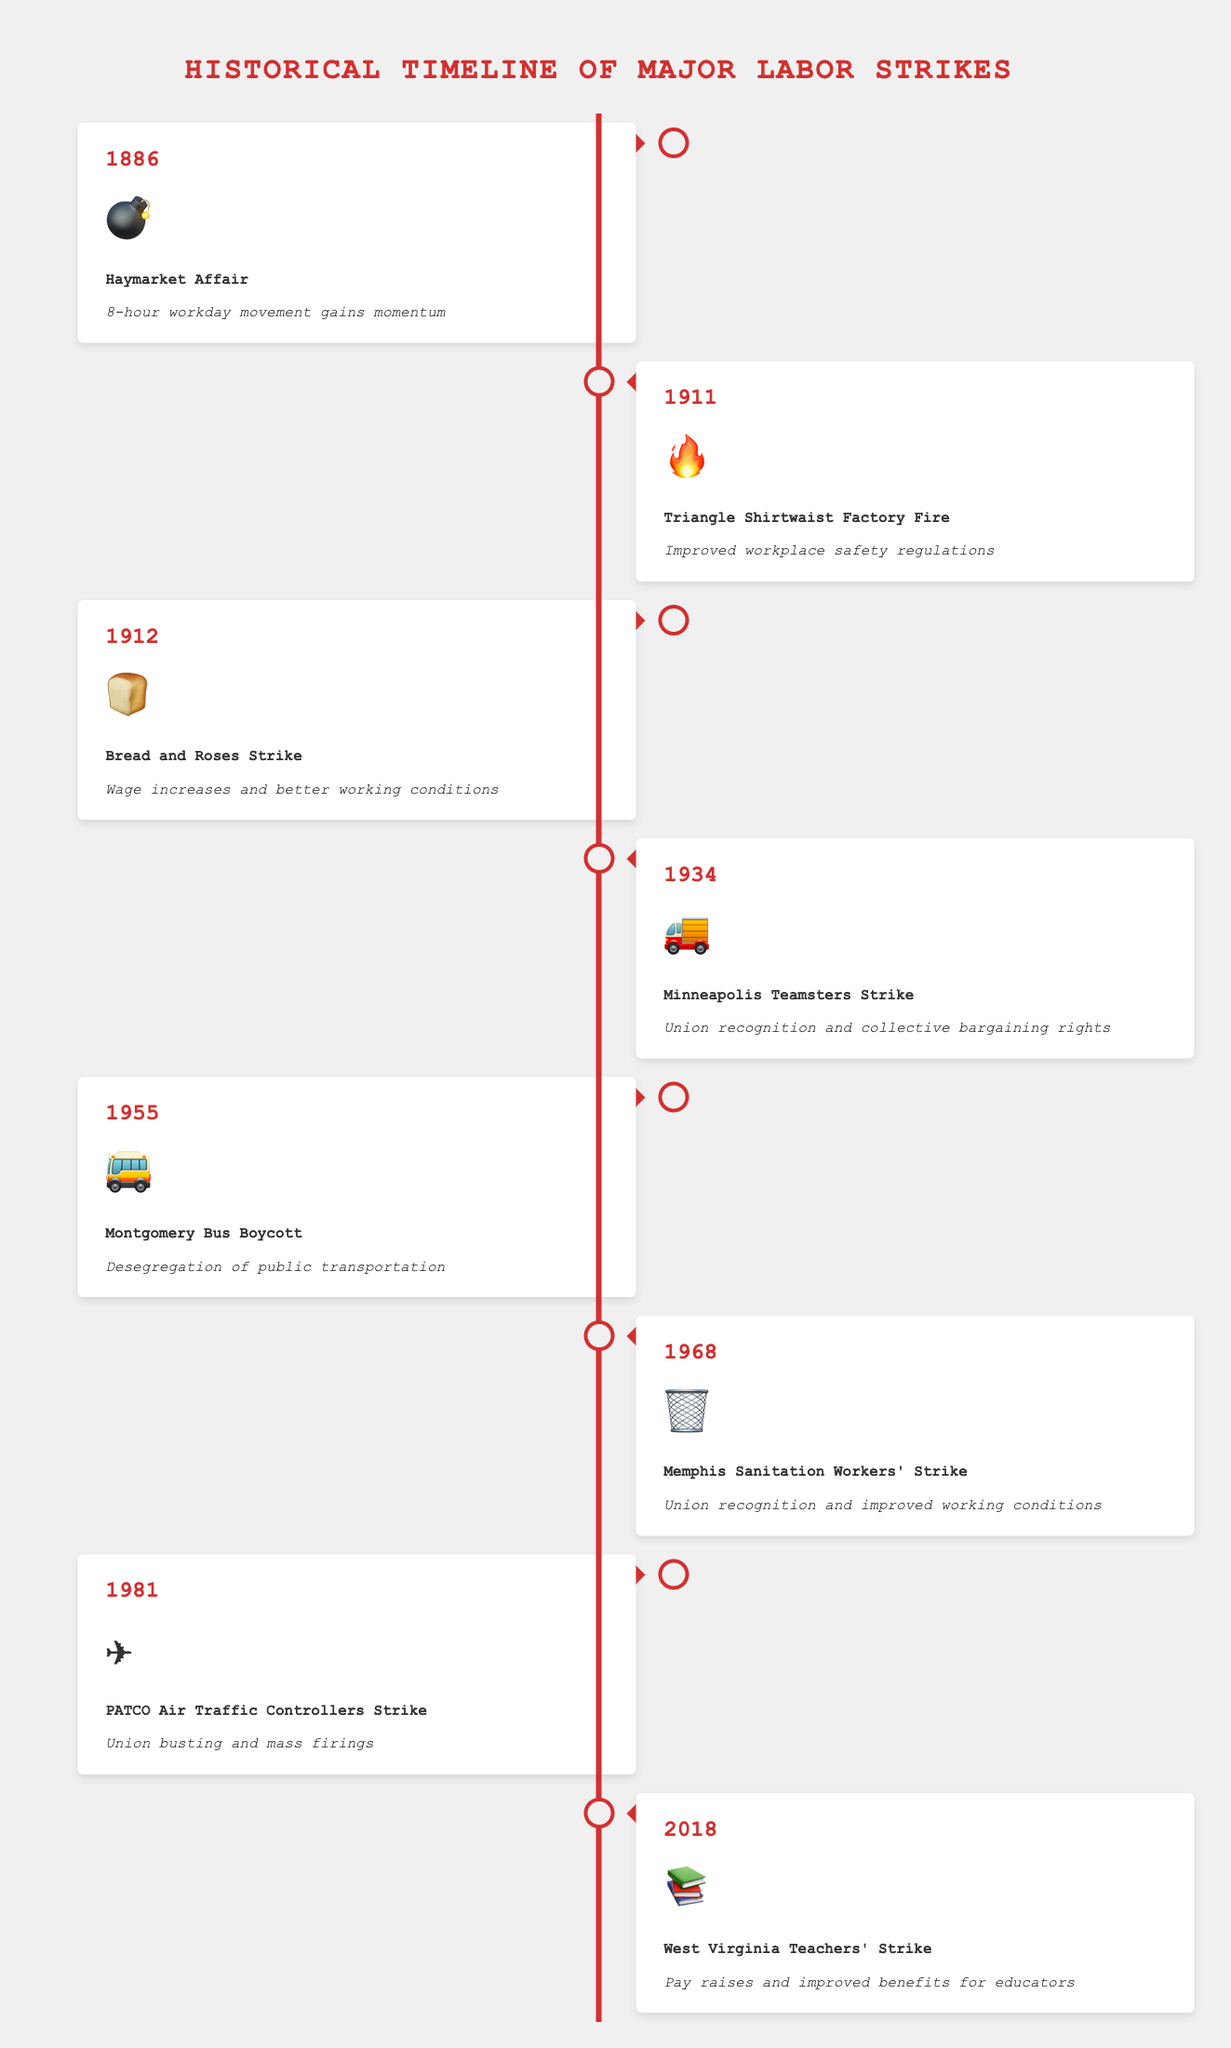When did the Haymarket Affair occur, and what was its outcome? Look for the year labeled with the 💣 emoji to identify the Haymarket Affair and read its corresponding outcome.
Answer: 1886; 8-hour workday movement gains momentum What major event happened in 1911, and what was its impact? Check the year 1911 and the associated event and outcome in the timeline.
Answer: Triangle Shirtwaist Factory Fire; Improved workplace safety regulations Which strike is represented by the 📚 emoji, and what was achieved? Locate the 📚 emoji to find the event and its outcome.
Answer: West Virginia Teachers' Strike; Pay raises and improved benefits for educators What two strikes occurred before 1955, and what were their outcomes? Identify the events before 1955, which are labeled with their respective emojis, and note their outcomes.
Answer: Haymarket Affair (1886; 8-hour workday movement gains momentum), Triangle Shirtwaist Factory Fire (1911; Improved workplace safety regulations), and Bread and Roses Strike (1912; Wage increases and better working conditions) What is the common outcome of strikes involving workplace safety reforms? Find all events related to improvements in workplace safety and summarize their outcomes.
Answer: Improved workplace safety regulations Compare the outcomes of the Memphis Sanitation Workers' Strike and PATCO Air Traffic Controllers Strike. Locate the Memphis Sanitation Workers' Strike (🗑️) and PATCO Air Traffic Controllers Strike (✈️) and read their outcomes.
Answer: Memphis: Union recognition and improved working conditions; PATCO: Union busting and mass firings Which event had the outcome of desegregation of public transportation, and in what year did it occur? Look for the event related to desegregation of public transportation and note its year.
Answer: Montgomery Bus Boycott; 1955 What were the outcomes of labor strikes that happened after 1980? Identify events after 1980 and summarize their outcomes.
Answer: PATCO Air Traffic Controllers Strike (1981; Union busting and mass firings), West Virginia Teachers' Strike (2018; Pay raises and improved benefits for educators) How many strikes between 1912 and 1968 were depicted, and what were their outcomes? Count the strikes between these years and summarize their outcomes.
Answer: Three strikes: Bread and Roses Strike (1912; Wage increases and better working conditions), Minneapolis Teamsters Strike (1934; Union recognition and collective bargaining rights), Memphis Sanitation Workers' Strike (1968; Union recognition and improved working conditions) Which strike was represented by the emoji 🚚 and what was its significance? Locate the 🚚 emoji and determine the event and significance.
Answer: Minneapolis Teamsters Strike; Union recognition and collective bargaining rights 